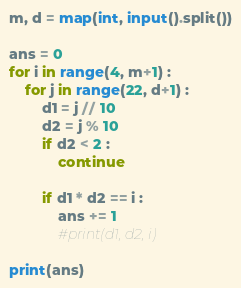<code> <loc_0><loc_0><loc_500><loc_500><_Python_>m, d = map(int, input().split())

ans = 0
for i in range(4, m+1) :
    for j in range(22, d+1) :
        d1 = j // 10
        d2 = j % 10
        if d2 < 2 :
            continue

        if d1 * d2 == i :
            ans += 1
            #print(d1, d2, i)

print(ans)
</code> 